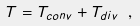Convert formula to latex. <formula><loc_0><loc_0><loc_500><loc_500>T = T _ { c o n v } + T _ { d i v } \ ,</formula> 